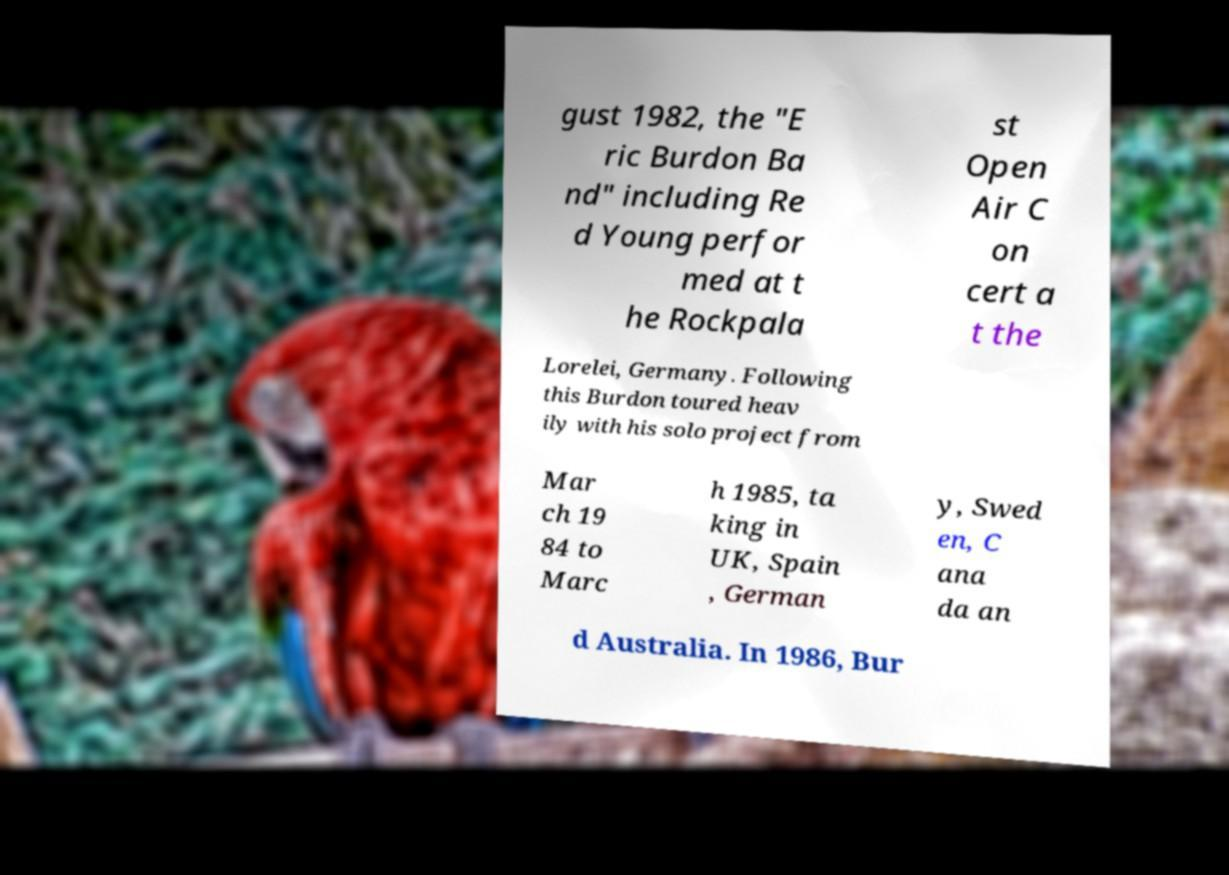For documentation purposes, I need the text within this image transcribed. Could you provide that? gust 1982, the "E ric Burdon Ba nd" including Re d Young perfor med at t he Rockpala st Open Air C on cert a t the Lorelei, Germany. Following this Burdon toured heav ily with his solo project from Mar ch 19 84 to Marc h 1985, ta king in UK, Spain , German y, Swed en, C ana da an d Australia. In 1986, Bur 